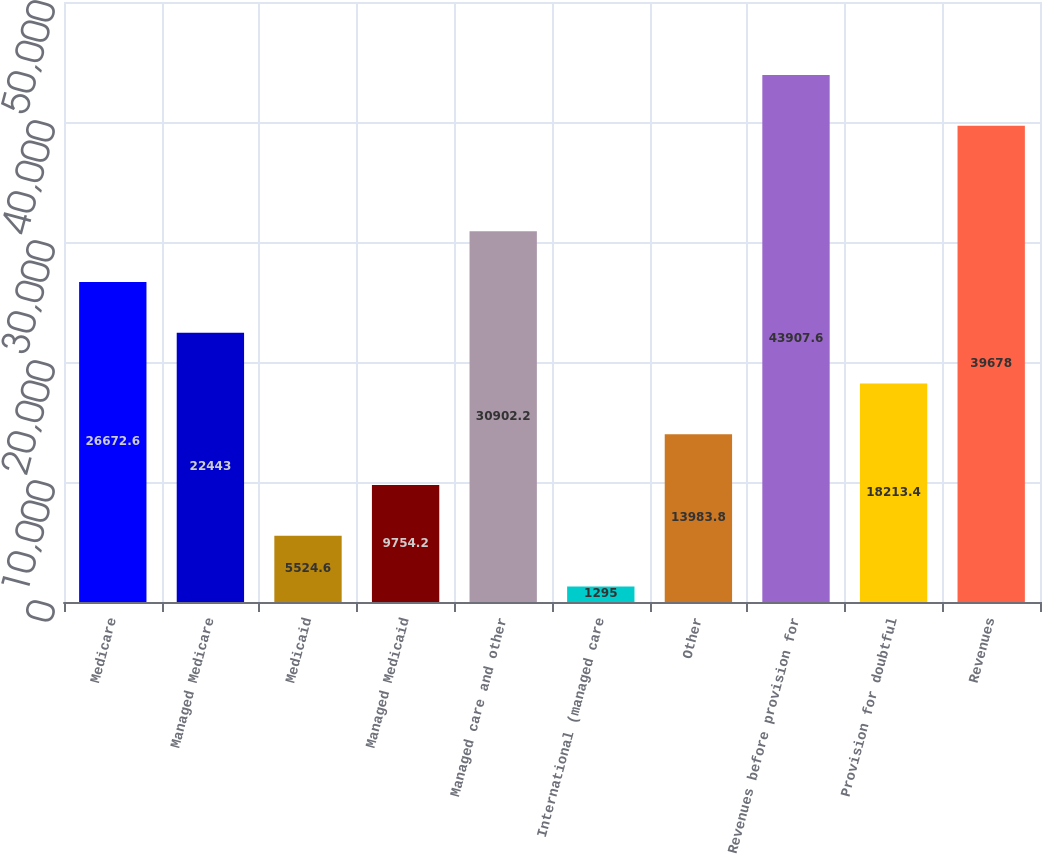<chart> <loc_0><loc_0><loc_500><loc_500><bar_chart><fcel>Medicare<fcel>Managed Medicare<fcel>Medicaid<fcel>Managed Medicaid<fcel>Managed care and other<fcel>International (managed care<fcel>Other<fcel>Revenues before provision for<fcel>Provision for doubtful<fcel>Revenues<nl><fcel>26672.6<fcel>22443<fcel>5524.6<fcel>9754.2<fcel>30902.2<fcel>1295<fcel>13983.8<fcel>43907.6<fcel>18213.4<fcel>39678<nl></chart> 